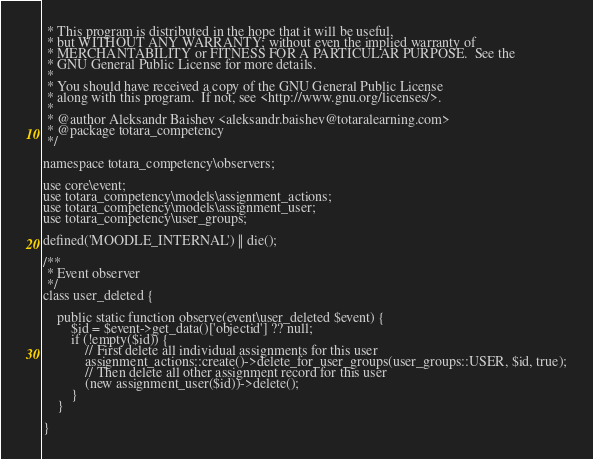<code> <loc_0><loc_0><loc_500><loc_500><_PHP_> * This program is distributed in the hope that it will be useful,
 * but WITHOUT ANY WARRANTY; without even the implied warranty of
 * MERCHANTABILITY or FITNESS FOR A PARTICULAR PURPOSE.  See the
 * GNU General Public License for more details.
 *
 * You should have received a copy of the GNU General Public License
 * along with this program.  If not, see <http://www.gnu.org/licenses/>.
 *
 * @author Aleksandr Baishev <aleksandr.baishev@totaralearning.com>
 * @package totara_competency
 */

namespace totara_competency\observers;

use core\event;
use totara_competency\models\assignment_actions;
use totara_competency\models\assignment_user;
use totara_competency\user_groups;

defined('MOODLE_INTERNAL') || die();

/**
 * Event observer
 */
class user_deleted {

    public static function observe(event\user_deleted $event) {
        $id = $event->get_data()['objectid'] ?? null;
        if (!empty($id)) {
            // First delete all individual assignments for this user
            assignment_actions::create()->delete_for_user_groups(user_groups::USER, $id, true);
            // Then delete all other assignment record for this user
            (new assignment_user($id))->delete();
        }
    }

}
</code> 